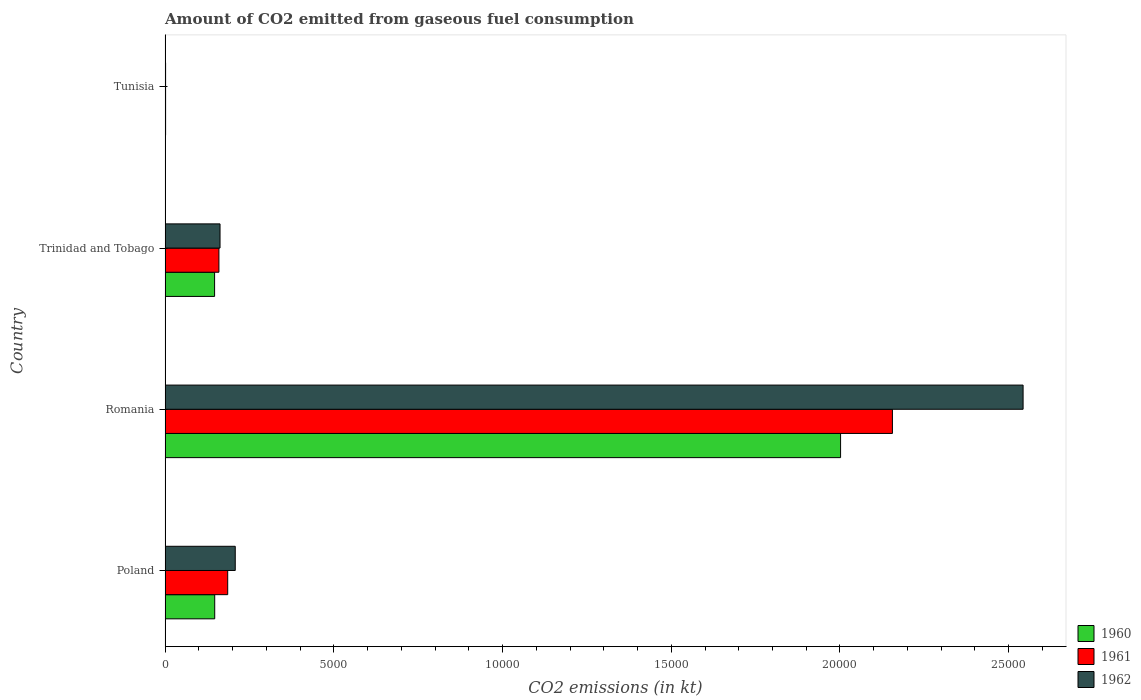Are the number of bars per tick equal to the number of legend labels?
Ensure brevity in your answer.  Yes. Are the number of bars on each tick of the Y-axis equal?
Offer a terse response. Yes. How many bars are there on the 1st tick from the bottom?
Provide a succinct answer. 3. What is the label of the 2nd group of bars from the top?
Make the answer very short. Trinidad and Tobago. What is the amount of CO2 emitted in 1960 in Tunisia?
Provide a succinct answer. 14.67. Across all countries, what is the maximum amount of CO2 emitted in 1962?
Your answer should be very brief. 2.54e+04. Across all countries, what is the minimum amount of CO2 emitted in 1961?
Provide a short and direct response. 14.67. In which country was the amount of CO2 emitted in 1960 maximum?
Offer a terse response. Romania. In which country was the amount of CO2 emitted in 1961 minimum?
Provide a short and direct response. Tunisia. What is the total amount of CO2 emitted in 1962 in the graph?
Your answer should be very brief. 2.91e+04. What is the difference between the amount of CO2 emitted in 1960 in Romania and that in Trinidad and Tobago?
Ensure brevity in your answer.  1.86e+04. What is the difference between the amount of CO2 emitted in 1962 in Romania and the amount of CO2 emitted in 1960 in Tunisia?
Your response must be concise. 2.54e+04. What is the average amount of CO2 emitted in 1960 per country?
Offer a terse response. 5742.52. What is the difference between the amount of CO2 emitted in 1962 and amount of CO2 emitted in 1960 in Tunisia?
Offer a very short reply. 0. What is the ratio of the amount of CO2 emitted in 1960 in Trinidad and Tobago to that in Tunisia?
Provide a succinct answer. 100. Is the amount of CO2 emitted in 1960 in Romania less than that in Trinidad and Tobago?
Provide a succinct answer. No. Is the difference between the amount of CO2 emitted in 1962 in Poland and Tunisia greater than the difference between the amount of CO2 emitted in 1960 in Poland and Tunisia?
Ensure brevity in your answer.  Yes. What is the difference between the highest and the second highest amount of CO2 emitted in 1961?
Ensure brevity in your answer.  1.97e+04. What is the difference between the highest and the lowest amount of CO2 emitted in 1961?
Offer a very short reply. 2.15e+04. In how many countries, is the amount of CO2 emitted in 1962 greater than the average amount of CO2 emitted in 1962 taken over all countries?
Ensure brevity in your answer.  1. What does the 3rd bar from the bottom in Tunisia represents?
Ensure brevity in your answer.  1962. How many bars are there?
Keep it short and to the point. 12. Are all the bars in the graph horizontal?
Give a very brief answer. Yes. How many countries are there in the graph?
Make the answer very short. 4. What is the difference between two consecutive major ticks on the X-axis?
Ensure brevity in your answer.  5000. Are the values on the major ticks of X-axis written in scientific E-notation?
Offer a very short reply. No. Does the graph contain any zero values?
Your answer should be very brief. No. Does the graph contain grids?
Provide a succinct answer. No. How many legend labels are there?
Offer a terse response. 3. What is the title of the graph?
Make the answer very short. Amount of CO2 emitted from gaseous fuel consumption. What is the label or title of the X-axis?
Ensure brevity in your answer.  CO2 emissions (in kt). What is the CO2 emissions (in kt) of 1960 in Poland?
Provide a succinct answer. 1470.47. What is the CO2 emissions (in kt) of 1961 in Poland?
Provide a succinct answer. 1855.5. What is the CO2 emissions (in kt) of 1962 in Poland?
Ensure brevity in your answer.  2079.19. What is the CO2 emissions (in kt) of 1960 in Romania?
Offer a very short reply. 2.00e+04. What is the CO2 emissions (in kt) in 1961 in Romania?
Offer a terse response. 2.16e+04. What is the CO2 emissions (in kt) of 1962 in Romania?
Make the answer very short. 2.54e+04. What is the CO2 emissions (in kt) in 1960 in Trinidad and Tobago?
Your response must be concise. 1466.8. What is the CO2 emissions (in kt) of 1961 in Trinidad and Tobago?
Make the answer very short. 1595.14. What is the CO2 emissions (in kt) in 1962 in Trinidad and Tobago?
Provide a short and direct response. 1628.15. What is the CO2 emissions (in kt) in 1960 in Tunisia?
Your response must be concise. 14.67. What is the CO2 emissions (in kt) in 1961 in Tunisia?
Your response must be concise. 14.67. What is the CO2 emissions (in kt) of 1962 in Tunisia?
Offer a very short reply. 14.67. Across all countries, what is the maximum CO2 emissions (in kt) of 1960?
Keep it short and to the point. 2.00e+04. Across all countries, what is the maximum CO2 emissions (in kt) in 1961?
Your answer should be very brief. 2.16e+04. Across all countries, what is the maximum CO2 emissions (in kt) of 1962?
Provide a short and direct response. 2.54e+04. Across all countries, what is the minimum CO2 emissions (in kt) of 1960?
Your answer should be compact. 14.67. Across all countries, what is the minimum CO2 emissions (in kt) in 1961?
Your answer should be compact. 14.67. Across all countries, what is the minimum CO2 emissions (in kt) of 1962?
Offer a terse response. 14.67. What is the total CO2 emissions (in kt) in 1960 in the graph?
Your answer should be compact. 2.30e+04. What is the total CO2 emissions (in kt) of 1961 in the graph?
Ensure brevity in your answer.  2.50e+04. What is the total CO2 emissions (in kt) of 1962 in the graph?
Ensure brevity in your answer.  2.91e+04. What is the difference between the CO2 emissions (in kt) in 1960 in Poland and that in Romania?
Offer a very short reply. -1.85e+04. What is the difference between the CO2 emissions (in kt) of 1961 in Poland and that in Romania?
Ensure brevity in your answer.  -1.97e+04. What is the difference between the CO2 emissions (in kt) of 1962 in Poland and that in Romania?
Your response must be concise. -2.33e+04. What is the difference between the CO2 emissions (in kt) of 1960 in Poland and that in Trinidad and Tobago?
Offer a terse response. 3.67. What is the difference between the CO2 emissions (in kt) of 1961 in Poland and that in Trinidad and Tobago?
Your answer should be very brief. 260.36. What is the difference between the CO2 emissions (in kt) in 1962 in Poland and that in Trinidad and Tobago?
Your response must be concise. 451.04. What is the difference between the CO2 emissions (in kt) in 1960 in Poland and that in Tunisia?
Offer a very short reply. 1455.8. What is the difference between the CO2 emissions (in kt) of 1961 in Poland and that in Tunisia?
Ensure brevity in your answer.  1840.83. What is the difference between the CO2 emissions (in kt) of 1962 in Poland and that in Tunisia?
Make the answer very short. 2064.52. What is the difference between the CO2 emissions (in kt) of 1960 in Romania and that in Trinidad and Tobago?
Ensure brevity in your answer.  1.86e+04. What is the difference between the CO2 emissions (in kt) in 1961 in Romania and that in Trinidad and Tobago?
Offer a very short reply. 2.00e+04. What is the difference between the CO2 emissions (in kt) of 1962 in Romania and that in Trinidad and Tobago?
Offer a terse response. 2.38e+04. What is the difference between the CO2 emissions (in kt) in 1960 in Romania and that in Tunisia?
Offer a terse response. 2.00e+04. What is the difference between the CO2 emissions (in kt) in 1961 in Romania and that in Tunisia?
Offer a very short reply. 2.15e+04. What is the difference between the CO2 emissions (in kt) of 1962 in Romania and that in Tunisia?
Your answer should be very brief. 2.54e+04. What is the difference between the CO2 emissions (in kt) of 1960 in Trinidad and Tobago and that in Tunisia?
Your answer should be very brief. 1452.13. What is the difference between the CO2 emissions (in kt) in 1961 in Trinidad and Tobago and that in Tunisia?
Provide a succinct answer. 1580.48. What is the difference between the CO2 emissions (in kt) in 1962 in Trinidad and Tobago and that in Tunisia?
Provide a short and direct response. 1613.48. What is the difference between the CO2 emissions (in kt) of 1960 in Poland and the CO2 emissions (in kt) of 1961 in Romania?
Provide a succinct answer. -2.01e+04. What is the difference between the CO2 emissions (in kt) in 1960 in Poland and the CO2 emissions (in kt) in 1962 in Romania?
Your answer should be compact. -2.40e+04. What is the difference between the CO2 emissions (in kt) in 1961 in Poland and the CO2 emissions (in kt) in 1962 in Romania?
Your response must be concise. -2.36e+04. What is the difference between the CO2 emissions (in kt) of 1960 in Poland and the CO2 emissions (in kt) of 1961 in Trinidad and Tobago?
Make the answer very short. -124.68. What is the difference between the CO2 emissions (in kt) of 1960 in Poland and the CO2 emissions (in kt) of 1962 in Trinidad and Tobago?
Provide a succinct answer. -157.68. What is the difference between the CO2 emissions (in kt) in 1961 in Poland and the CO2 emissions (in kt) in 1962 in Trinidad and Tobago?
Your answer should be very brief. 227.35. What is the difference between the CO2 emissions (in kt) in 1960 in Poland and the CO2 emissions (in kt) in 1961 in Tunisia?
Your response must be concise. 1455.8. What is the difference between the CO2 emissions (in kt) of 1960 in Poland and the CO2 emissions (in kt) of 1962 in Tunisia?
Keep it short and to the point. 1455.8. What is the difference between the CO2 emissions (in kt) of 1961 in Poland and the CO2 emissions (in kt) of 1962 in Tunisia?
Offer a terse response. 1840.83. What is the difference between the CO2 emissions (in kt) of 1960 in Romania and the CO2 emissions (in kt) of 1961 in Trinidad and Tobago?
Your response must be concise. 1.84e+04. What is the difference between the CO2 emissions (in kt) in 1960 in Romania and the CO2 emissions (in kt) in 1962 in Trinidad and Tobago?
Keep it short and to the point. 1.84e+04. What is the difference between the CO2 emissions (in kt) of 1961 in Romania and the CO2 emissions (in kt) of 1962 in Trinidad and Tobago?
Provide a succinct answer. 1.99e+04. What is the difference between the CO2 emissions (in kt) in 1960 in Romania and the CO2 emissions (in kt) in 1961 in Tunisia?
Keep it short and to the point. 2.00e+04. What is the difference between the CO2 emissions (in kt) in 1960 in Romania and the CO2 emissions (in kt) in 1962 in Tunisia?
Give a very brief answer. 2.00e+04. What is the difference between the CO2 emissions (in kt) of 1961 in Romania and the CO2 emissions (in kt) of 1962 in Tunisia?
Provide a short and direct response. 2.15e+04. What is the difference between the CO2 emissions (in kt) in 1960 in Trinidad and Tobago and the CO2 emissions (in kt) in 1961 in Tunisia?
Give a very brief answer. 1452.13. What is the difference between the CO2 emissions (in kt) in 1960 in Trinidad and Tobago and the CO2 emissions (in kt) in 1962 in Tunisia?
Offer a terse response. 1452.13. What is the difference between the CO2 emissions (in kt) in 1961 in Trinidad and Tobago and the CO2 emissions (in kt) in 1962 in Tunisia?
Provide a short and direct response. 1580.48. What is the average CO2 emissions (in kt) of 1960 per country?
Your response must be concise. 5742.52. What is the average CO2 emissions (in kt) in 1961 per country?
Your response must be concise. 6254.99. What is the average CO2 emissions (in kt) of 1962 per country?
Offer a terse response. 7287.25. What is the difference between the CO2 emissions (in kt) of 1960 and CO2 emissions (in kt) of 1961 in Poland?
Keep it short and to the point. -385.04. What is the difference between the CO2 emissions (in kt) in 1960 and CO2 emissions (in kt) in 1962 in Poland?
Provide a short and direct response. -608.72. What is the difference between the CO2 emissions (in kt) in 1961 and CO2 emissions (in kt) in 1962 in Poland?
Ensure brevity in your answer.  -223.69. What is the difference between the CO2 emissions (in kt) of 1960 and CO2 emissions (in kt) of 1961 in Romania?
Offer a very short reply. -1536.47. What is the difference between the CO2 emissions (in kt) of 1960 and CO2 emissions (in kt) of 1962 in Romania?
Provide a short and direct response. -5408.82. What is the difference between the CO2 emissions (in kt) of 1961 and CO2 emissions (in kt) of 1962 in Romania?
Offer a terse response. -3872.35. What is the difference between the CO2 emissions (in kt) of 1960 and CO2 emissions (in kt) of 1961 in Trinidad and Tobago?
Your response must be concise. -128.34. What is the difference between the CO2 emissions (in kt) of 1960 and CO2 emissions (in kt) of 1962 in Trinidad and Tobago?
Your answer should be compact. -161.35. What is the difference between the CO2 emissions (in kt) in 1961 and CO2 emissions (in kt) in 1962 in Trinidad and Tobago?
Ensure brevity in your answer.  -33. What is the difference between the CO2 emissions (in kt) in 1960 and CO2 emissions (in kt) in 1962 in Tunisia?
Your answer should be compact. 0. What is the ratio of the CO2 emissions (in kt) in 1960 in Poland to that in Romania?
Make the answer very short. 0.07. What is the ratio of the CO2 emissions (in kt) in 1961 in Poland to that in Romania?
Ensure brevity in your answer.  0.09. What is the ratio of the CO2 emissions (in kt) of 1962 in Poland to that in Romania?
Your response must be concise. 0.08. What is the ratio of the CO2 emissions (in kt) in 1960 in Poland to that in Trinidad and Tobago?
Ensure brevity in your answer.  1. What is the ratio of the CO2 emissions (in kt) in 1961 in Poland to that in Trinidad and Tobago?
Offer a very short reply. 1.16. What is the ratio of the CO2 emissions (in kt) in 1962 in Poland to that in Trinidad and Tobago?
Provide a short and direct response. 1.28. What is the ratio of the CO2 emissions (in kt) of 1960 in Poland to that in Tunisia?
Make the answer very short. 100.25. What is the ratio of the CO2 emissions (in kt) in 1961 in Poland to that in Tunisia?
Offer a terse response. 126.5. What is the ratio of the CO2 emissions (in kt) in 1962 in Poland to that in Tunisia?
Give a very brief answer. 141.75. What is the ratio of the CO2 emissions (in kt) of 1960 in Romania to that in Trinidad and Tobago?
Your answer should be very brief. 13.65. What is the ratio of the CO2 emissions (in kt) of 1961 in Romania to that in Trinidad and Tobago?
Make the answer very short. 13.51. What is the ratio of the CO2 emissions (in kt) in 1962 in Romania to that in Trinidad and Tobago?
Give a very brief answer. 15.62. What is the ratio of the CO2 emissions (in kt) of 1960 in Romania to that in Tunisia?
Ensure brevity in your answer.  1364.75. What is the ratio of the CO2 emissions (in kt) in 1961 in Romania to that in Tunisia?
Offer a terse response. 1469.5. What is the ratio of the CO2 emissions (in kt) in 1962 in Romania to that in Tunisia?
Keep it short and to the point. 1733.5. What is the ratio of the CO2 emissions (in kt) of 1960 in Trinidad and Tobago to that in Tunisia?
Make the answer very short. 100. What is the ratio of the CO2 emissions (in kt) in 1961 in Trinidad and Tobago to that in Tunisia?
Provide a short and direct response. 108.75. What is the ratio of the CO2 emissions (in kt) of 1962 in Trinidad and Tobago to that in Tunisia?
Give a very brief answer. 111. What is the difference between the highest and the second highest CO2 emissions (in kt) of 1960?
Your answer should be compact. 1.85e+04. What is the difference between the highest and the second highest CO2 emissions (in kt) of 1961?
Your answer should be compact. 1.97e+04. What is the difference between the highest and the second highest CO2 emissions (in kt) of 1962?
Make the answer very short. 2.33e+04. What is the difference between the highest and the lowest CO2 emissions (in kt) of 1960?
Provide a short and direct response. 2.00e+04. What is the difference between the highest and the lowest CO2 emissions (in kt) in 1961?
Your answer should be compact. 2.15e+04. What is the difference between the highest and the lowest CO2 emissions (in kt) in 1962?
Your answer should be compact. 2.54e+04. 